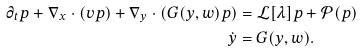<formula> <loc_0><loc_0><loc_500><loc_500>\partial _ { t } p + \nabla _ { x } \cdot ( v p ) + \nabla _ { y } \cdot ( G ( y , w ) p ) & = \mathcal { L } [ \lambda ] p + \mathcal { P } ( p ) \\ \dot { y } & = G ( y , w ) .</formula> 